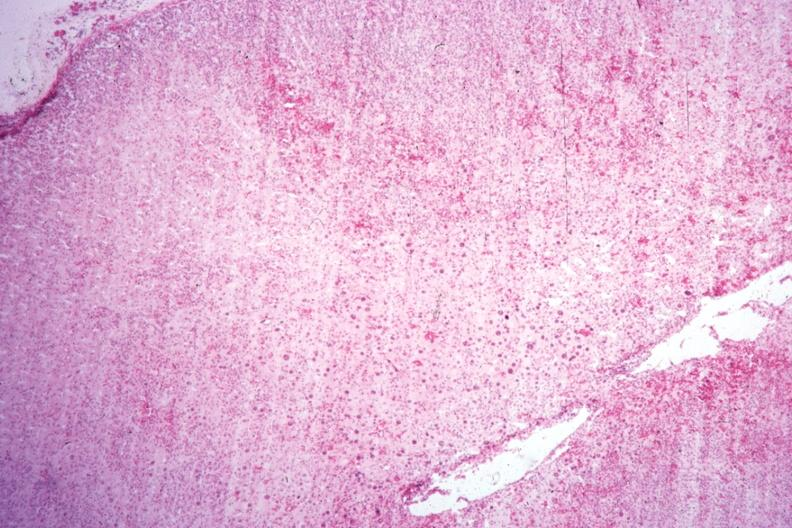does this image show localization of cytomegaly well shown?
Answer the question using a single word or phrase. Yes 